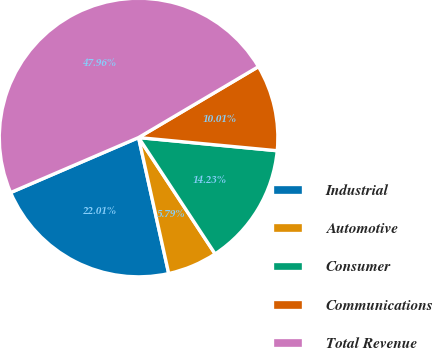Convert chart. <chart><loc_0><loc_0><loc_500><loc_500><pie_chart><fcel>Industrial<fcel>Automotive<fcel>Consumer<fcel>Communications<fcel>Total Revenue<nl><fcel>22.01%<fcel>5.79%<fcel>14.23%<fcel>10.01%<fcel>47.96%<nl></chart> 